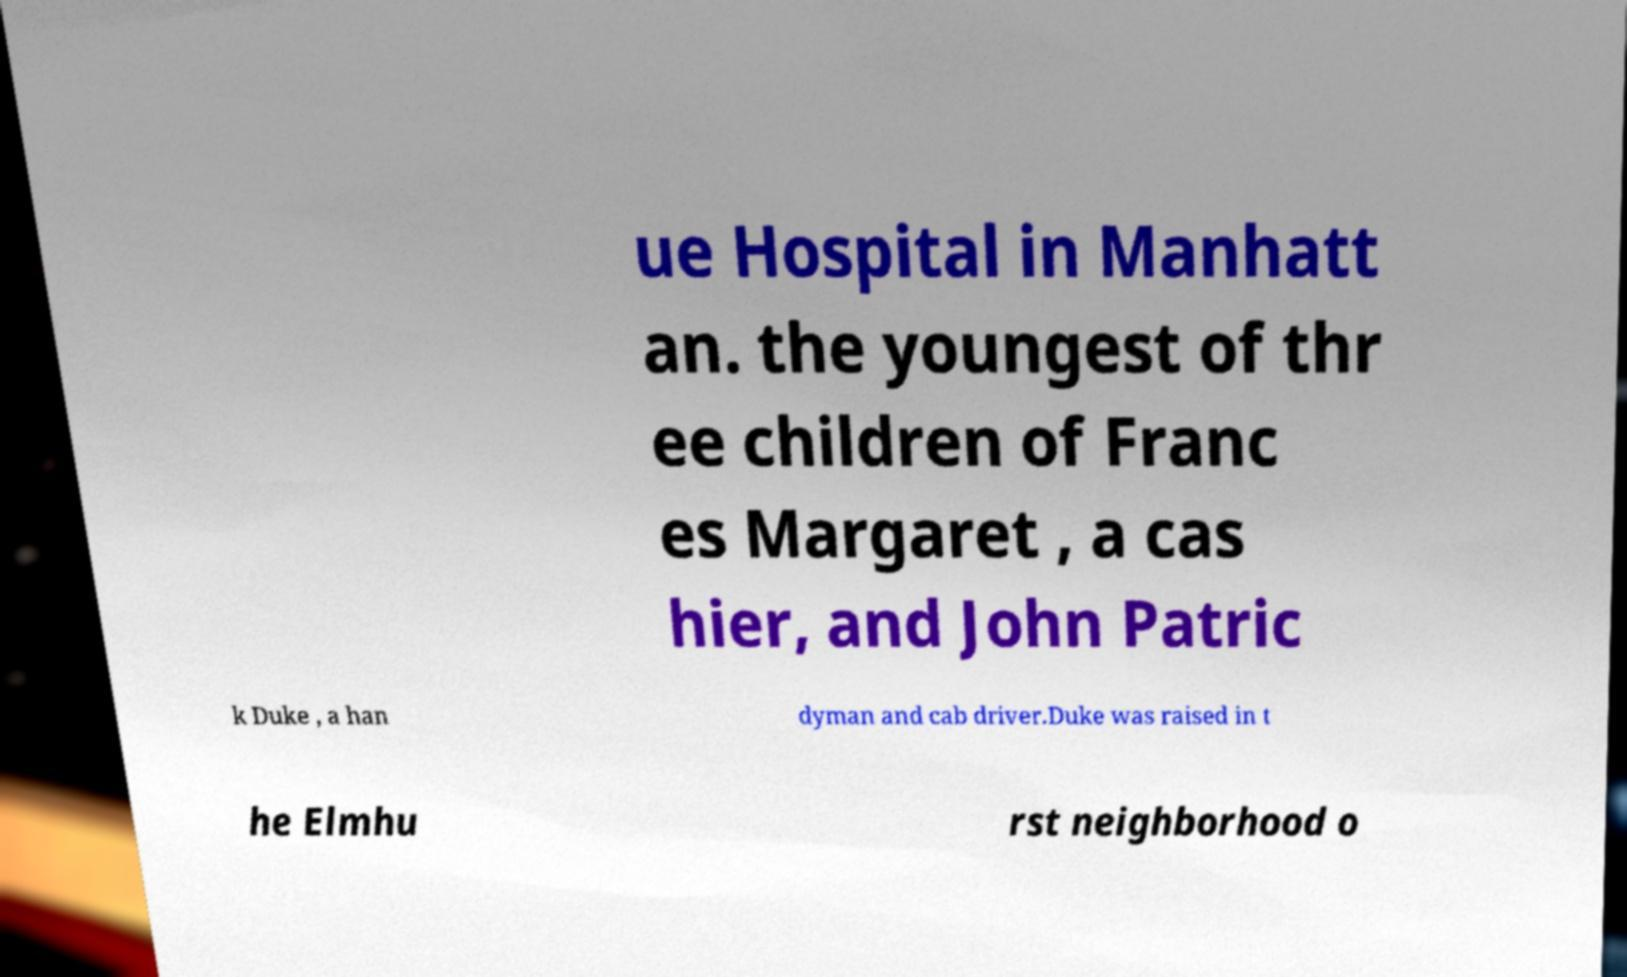There's text embedded in this image that I need extracted. Can you transcribe it verbatim? ue Hospital in Manhatt an. the youngest of thr ee children of Franc es Margaret , a cas hier, and John Patric k Duke , a han dyman and cab driver.Duke was raised in t he Elmhu rst neighborhood o 